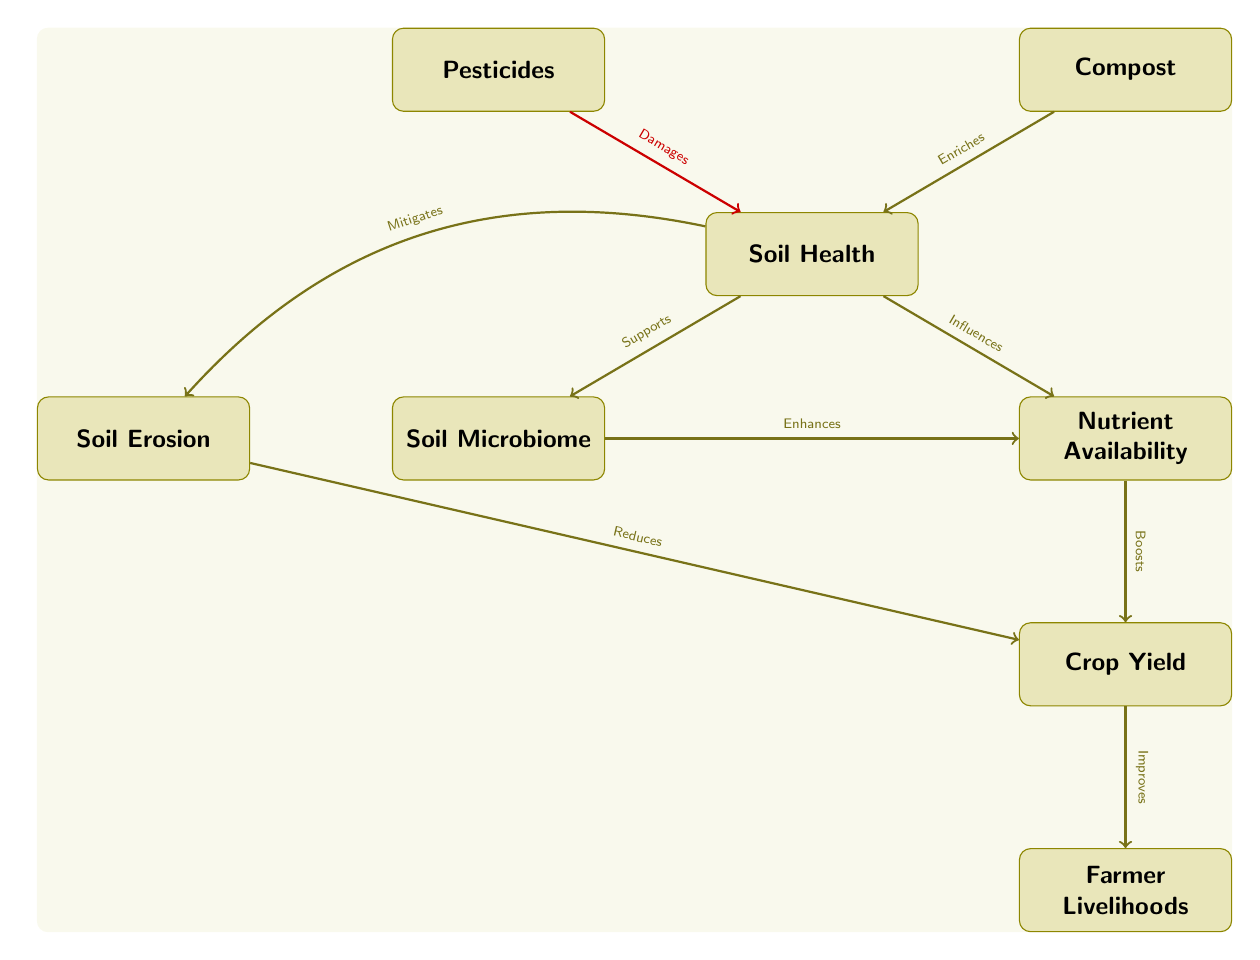What is the central concept of the diagram? The central concept represented at the top of the diagram is "Soil Health," from which various relationships and effects branch out.
Answer: Soil Health How many entities are depicted in the diagram? By counting the rectangles that represent the entities in the diagram, there are a total of six entities shown.
Answer: 6 What does "Soil Health" support? The arrow leading from "Soil Health" indicates it supports the "Soil Microbiome," establishing a beneficial relationship.
Answer: Soil Microbiome Which entity is influenced by "Soil Health"? The diagram shows an arrow from "Soil Health" towards "Nutrient Availability," indicating that soil health has an influence on nutrient levels available in the soil.
Answer: Nutrient Availability What is the relationship between "Nutrient Availability" and "Crop Yield"? There is a direct relationship depicted with the phrase "Boosts," indicating that nutrient availability positively contributes to crop yield.
Answer: Boosts If "Soil Erosion" increases, what effect does it have on "Crop Yield"? The diagram indicates that "Soil Erosion" has a negative effect on "Crop Yield," with the arrow labeled "Reduces" showing this relationship.
Answer: Reduces How does "Compost" affect "Soil Health"? The arrow from "Compost" to "Soil Health" is labeled "Enriches," reflecting the beneficial impact compost has on improving soil health.
Answer: Enriches What negative impact does "Pesticides" have on "Soil Health"? The arrow from "Pesticides" to "Soil Health" is labeled "Damages," which shows that pesticides negatively affect soil health.
Answer: Damages What is the ultimate outcome of improved "Crop Yield" as indicated in the diagram? The connection in the diagram indicates that improved crop yield directly leads to better "Farmer Livelihoods," establishing a positive end goal.
Answer: Farmer Livelihoods 